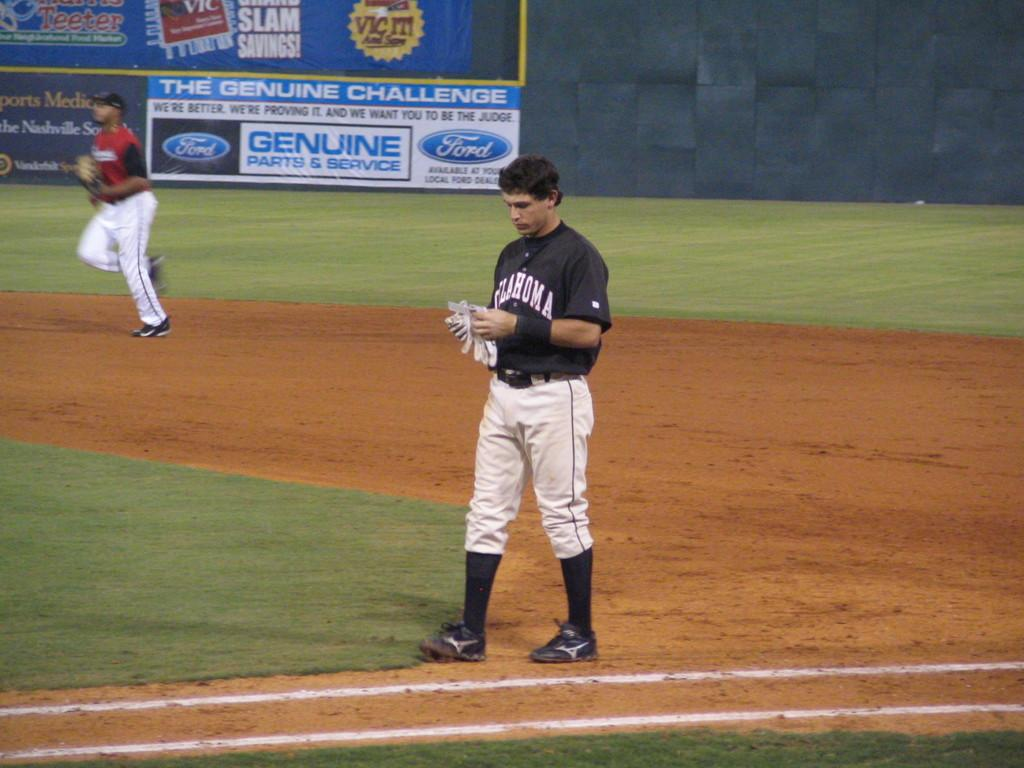<image>
Present a compact description of the photo's key features. An Oklahoma baseball player takes his batting gloves off. 